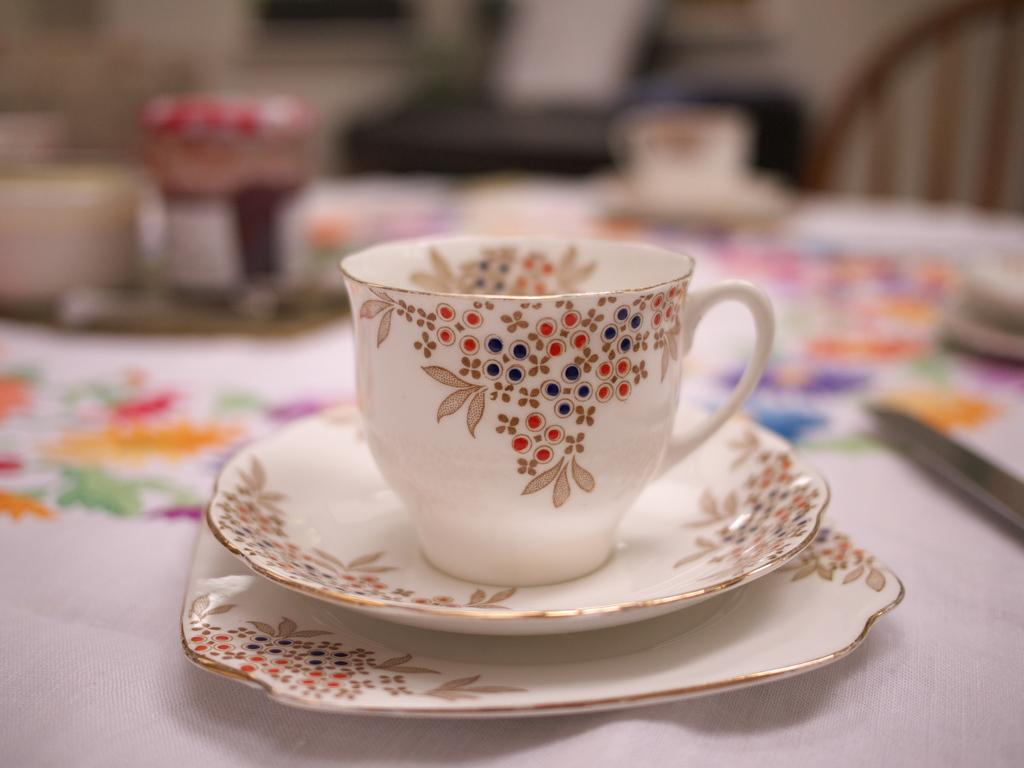What is placed on the tray in the image? There is a cup and saucer in the tray. What else is placed in the saucer? There is another cup in the saucer. Can you describe the objects on the table? There are vessels on the table. What type of joke is being told by the cup in the image? There is no indication in the image that the cup is telling a joke, as cups do not have the ability to speak or tell jokes. 